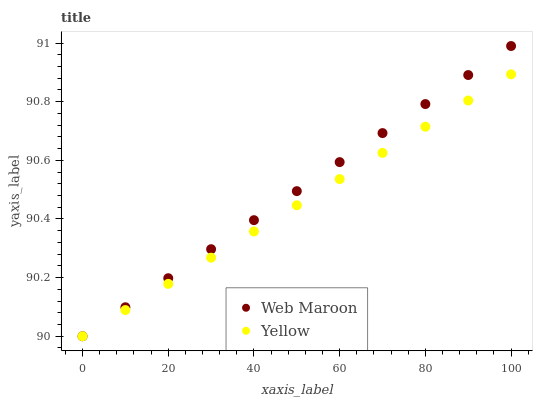Does Yellow have the minimum area under the curve?
Answer yes or no. Yes. Does Web Maroon have the maximum area under the curve?
Answer yes or no. Yes. Does Yellow have the maximum area under the curve?
Answer yes or no. No. Is Web Maroon the smoothest?
Answer yes or no. Yes. Is Yellow the roughest?
Answer yes or no. Yes. Is Yellow the smoothest?
Answer yes or no. No. Does Web Maroon have the lowest value?
Answer yes or no. Yes. Does Web Maroon have the highest value?
Answer yes or no. Yes. Does Yellow have the highest value?
Answer yes or no. No. Does Web Maroon intersect Yellow?
Answer yes or no. Yes. Is Web Maroon less than Yellow?
Answer yes or no. No. Is Web Maroon greater than Yellow?
Answer yes or no. No. 